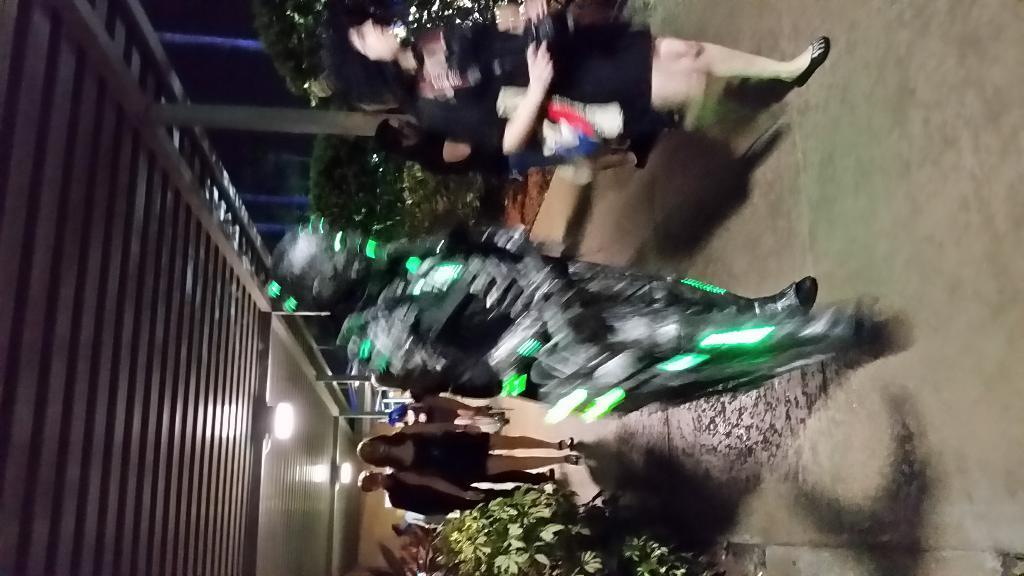In one or two sentences, can you explain what this image depicts? In this image, there are a few people. We can see the ground. We can see some plants. We can also see the shed with some lights and poles. 